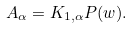Convert formula to latex. <formula><loc_0><loc_0><loc_500><loc_500>A _ { \alpha } = K _ { 1 , \alpha } P ( w ) .</formula> 